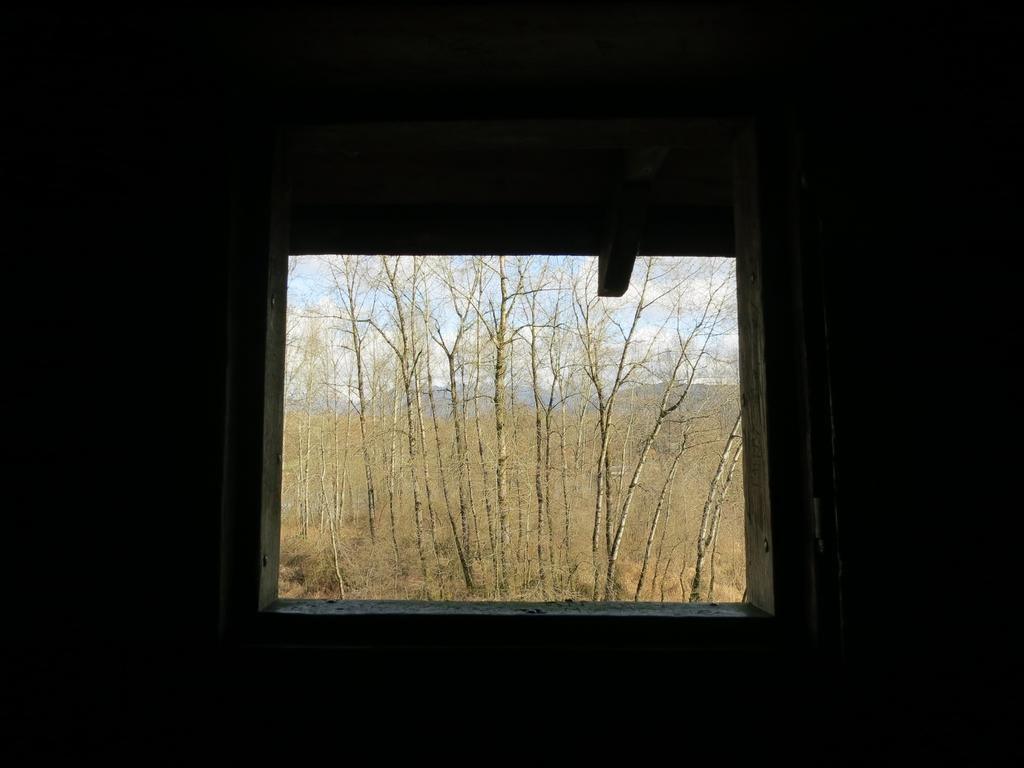Please provide a concise description of this image. In this picture we can observe a window. There are trees which are dried. In the background we can observe a sky. 